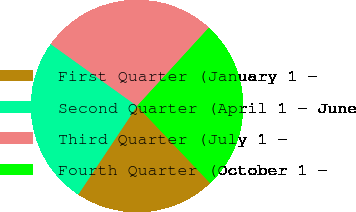Convert chart to OTSL. <chart><loc_0><loc_0><loc_500><loc_500><pie_chart><fcel>First Quarter (January 1 -<fcel>Second Quarter (April 1 - June<fcel>Third Quarter (July 1 -<fcel>Fourth Quarter (October 1 -<nl><fcel>21.41%<fcel>25.57%<fcel>26.9%<fcel>26.12%<nl></chart> 